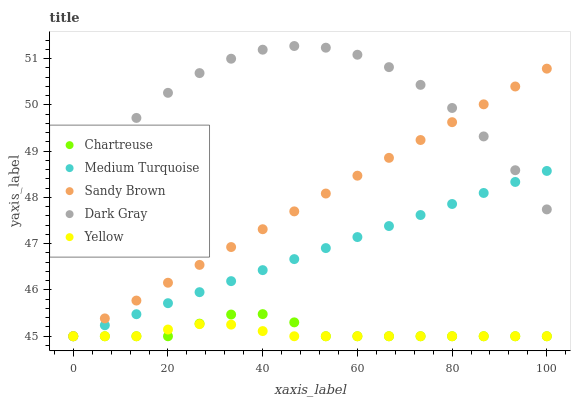Does Yellow have the minimum area under the curve?
Answer yes or no. Yes. Does Dark Gray have the maximum area under the curve?
Answer yes or no. Yes. Does Chartreuse have the minimum area under the curve?
Answer yes or no. No. Does Chartreuse have the maximum area under the curve?
Answer yes or no. No. Is Sandy Brown the smoothest?
Answer yes or no. Yes. Is Dark Gray the roughest?
Answer yes or no. Yes. Is Chartreuse the smoothest?
Answer yes or no. No. Is Chartreuse the roughest?
Answer yes or no. No. Does Chartreuse have the lowest value?
Answer yes or no. Yes. Does Dark Gray have the highest value?
Answer yes or no. Yes. Does Chartreuse have the highest value?
Answer yes or no. No. Is Chartreuse less than Dark Gray?
Answer yes or no. Yes. Is Dark Gray greater than Chartreuse?
Answer yes or no. Yes. Does Chartreuse intersect Sandy Brown?
Answer yes or no. Yes. Is Chartreuse less than Sandy Brown?
Answer yes or no. No. Is Chartreuse greater than Sandy Brown?
Answer yes or no. No. Does Chartreuse intersect Dark Gray?
Answer yes or no. No. 